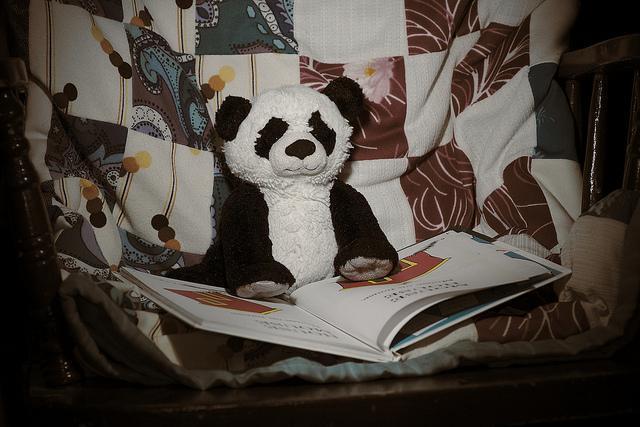Does the image validate the caption "The teddy bear is on the couch."?
Answer yes or no. Yes. 